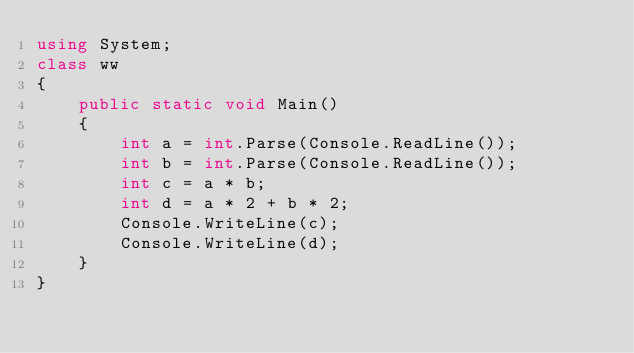<code> <loc_0><loc_0><loc_500><loc_500><_C#_>using System;
class ww
{
    public static void Main()
    {
        int a = int.Parse(Console.ReadLine());
        int b = int.Parse(Console.ReadLine());
        int c = a * b;
        int d = a * 2 + b * 2;
        Console.WriteLine(c);
        Console.WriteLine(d);
    }
}</code> 